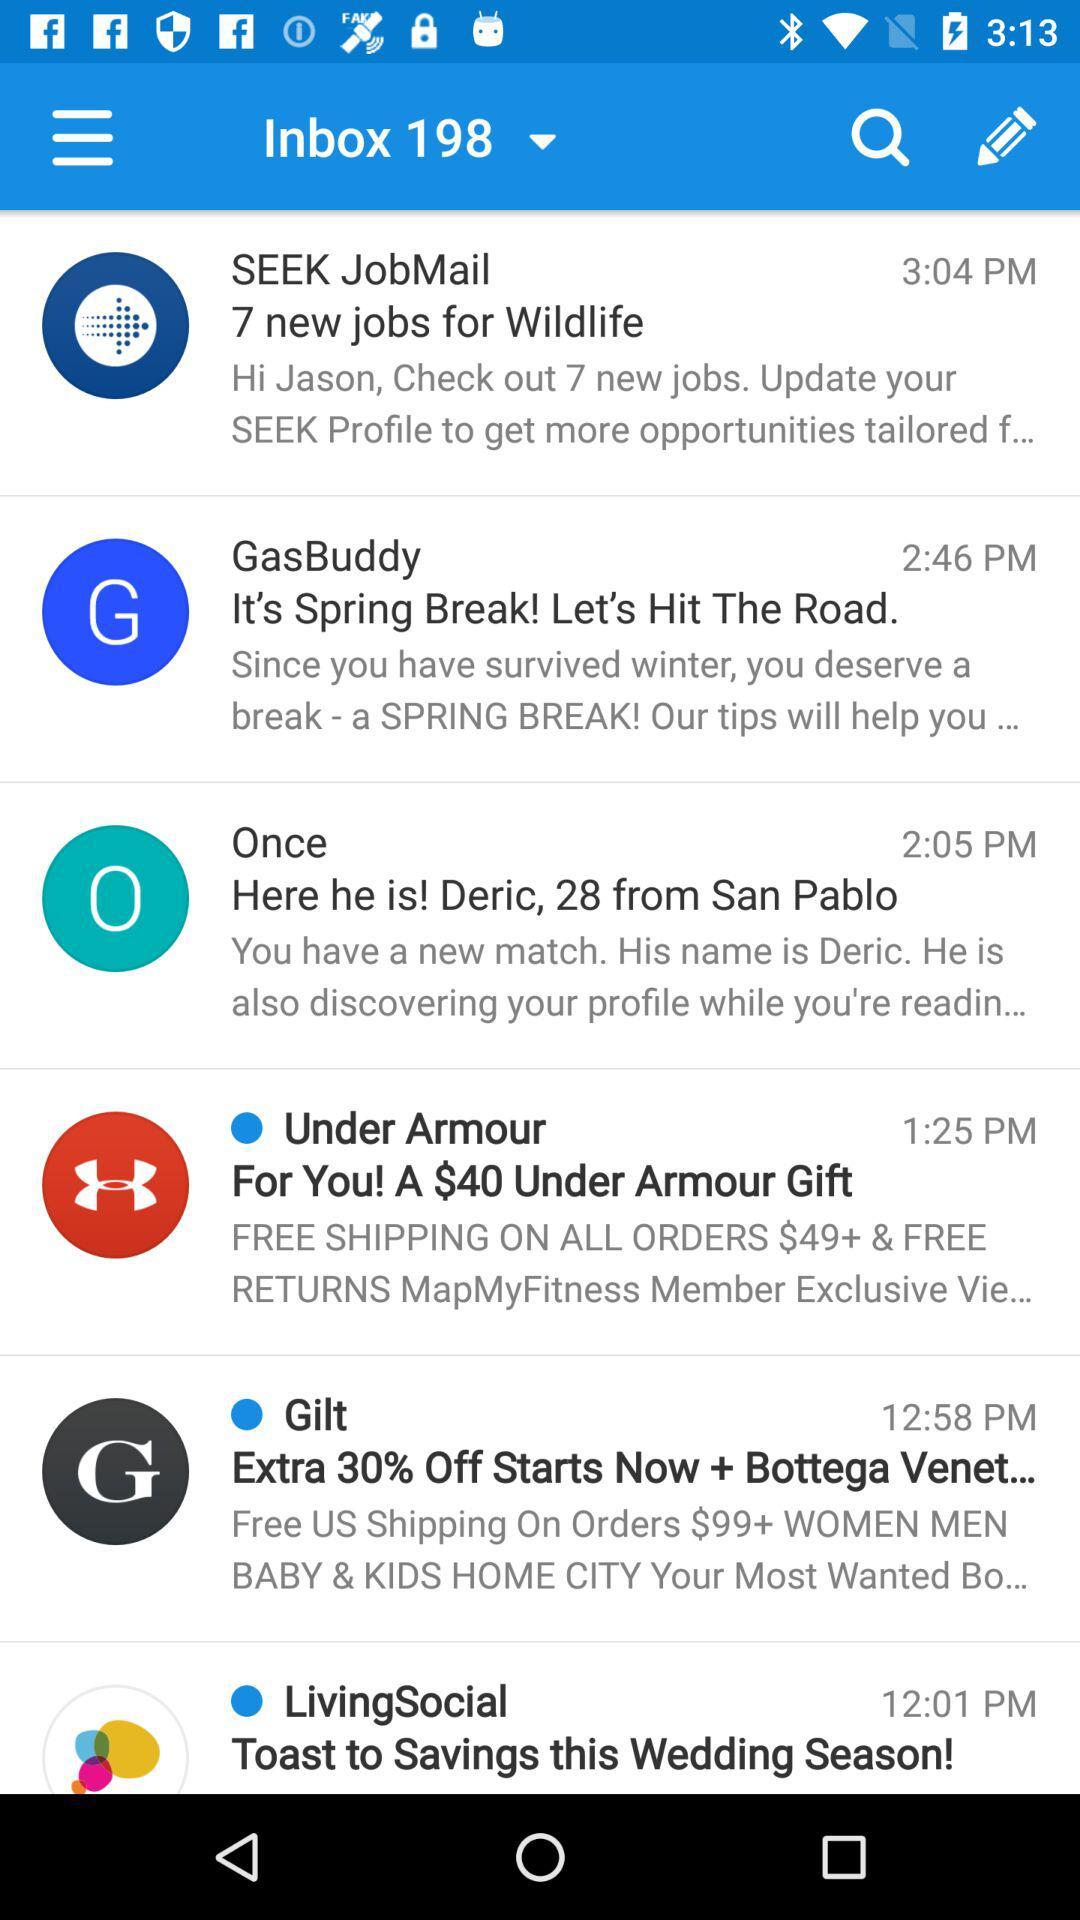How many total emails are there in the inbox? There are 198 emails. 